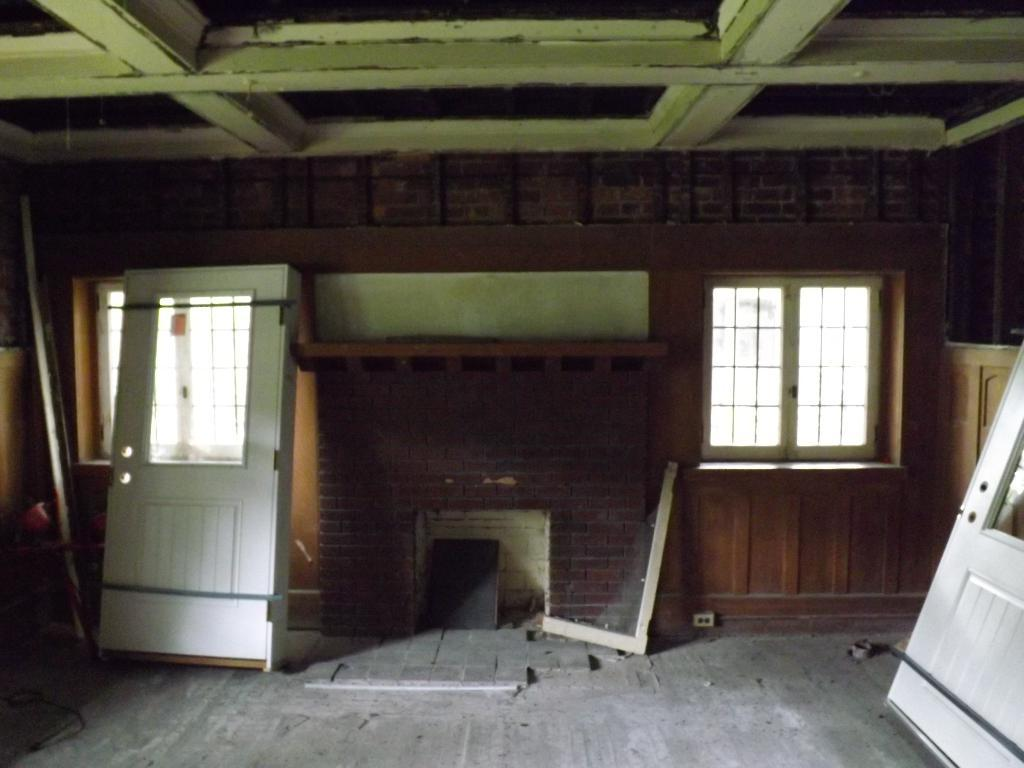What type of space is shown in the image? The image is an inside view of a room. What can be seen on the walls of the room? There are windows in the room. What are the boundaries of the room? There are walls in the room. How can one enter or exit the room? There are doors in the room. What is on the floor of the room? There is a broken object and other objects on the floor. How many flags are hanging on the walls in the image? There are no flags visible in the image. What type of knee injury can be seen on the person in the image? There are no people or knee injuries present in the image. 